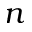<formula> <loc_0><loc_0><loc_500><loc_500>n</formula> 